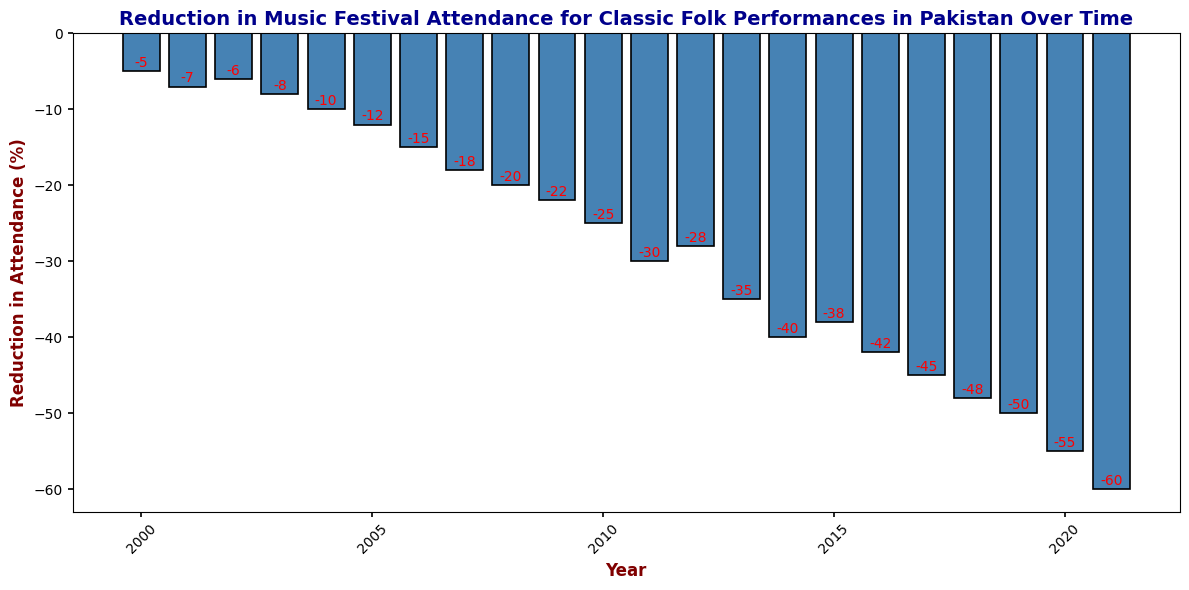What year had the highest reduction in attendance? The bar representing the year 2021 is the highest with a reduction in attendance of -60.
Answer: 2021 Between 2005 and 2010, which year saw the greatest reduction in attendance? Looking at the bars from 2005 to 2010, the year 2010 had the greatest reduction with -25.
Answer: 2010 By how much did the reduction in attendance increase from 2004 to 2005? The reduction in attendance in 2004 was -10 and in 2005 was -12. The increase is -12 - (-10) = -2.
Answer: -2 What is the average reduction in attendance for the years 2015 to 2020? Sum the reductions from 2015 to 2020: -38 + -42 + -45 + -48 + -50 + -55 = -278. There are 6 years, so the average is -278 / 6 = -46.33.
Answer: -46.33 Between which consecutive years was there the largest increase in the reduction? Observing the bars, the largest increase appears between 2010 and 2011, going from -25 to -30. The increase is -30 - (-25) = -5.
Answer: 2010 and 2011 What is the total reduction in attendance from 2018 to 2021? Sum the reductions from 2018 to 2021: -48 + -50 + -55 + -60 = -213.
Answer: -213 In which year did the reduction first exceed -20? The bar for 2009 shows the reduction first exceeding -20 with -22.
Answer: 2009 What is the difference in reduction between the years 2002 and 2007? The reduction in 2002 was -6, and in 2007 was -18. The difference is -18 - (-6) = -12.
Answer: -12 How does the reduction in attendance in 2013 compare to 2014? The reduction in 2013 was -35, and in 2014 it increased to -40.
Answer: Reduction increased from 2013 to 2014 What is the median reduction in attendance for the years 2000 to 2010? First, arrange the reductions: -5, -6, -7, -8, -10, -12, -15, -18, -20, -22, -25. There are 11 values, and the median is the 6th value: -12.
Answer: -12 